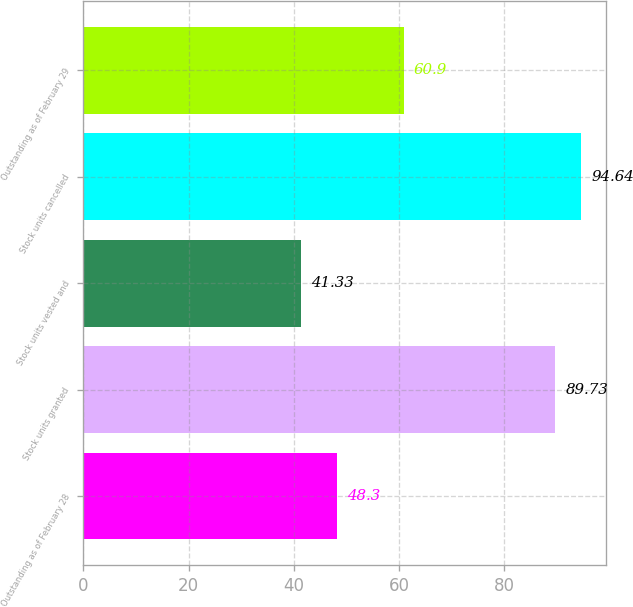<chart> <loc_0><loc_0><loc_500><loc_500><bar_chart><fcel>Outstanding as of February 28<fcel>Stock units granted<fcel>Stock units vested and<fcel>Stock units cancelled<fcel>Outstanding as of February 29<nl><fcel>48.3<fcel>89.73<fcel>41.33<fcel>94.64<fcel>60.9<nl></chart> 